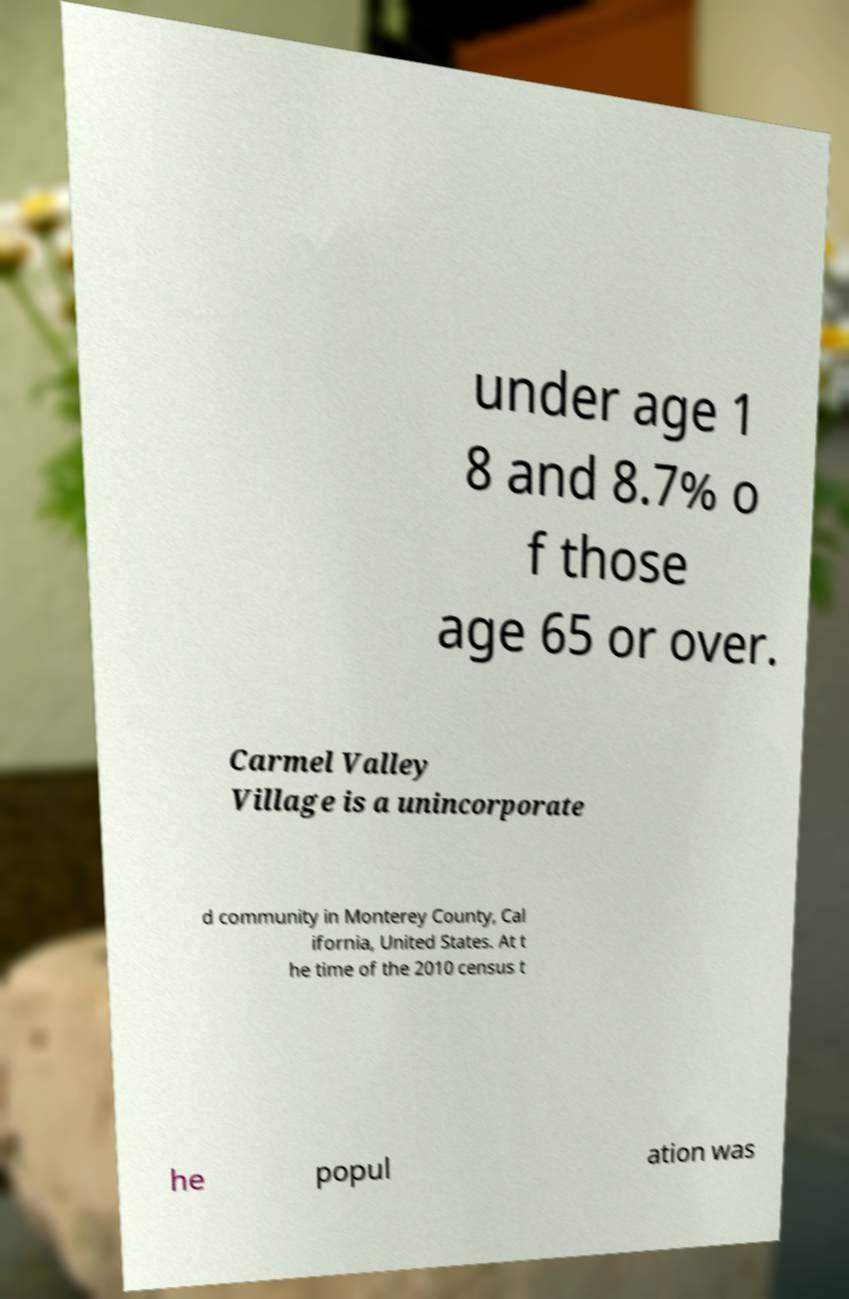Can you accurately transcribe the text from the provided image for me? under age 1 8 and 8.7% o f those age 65 or over. Carmel Valley Village is a unincorporate d community in Monterey County, Cal ifornia, United States. At t he time of the 2010 census t he popul ation was 